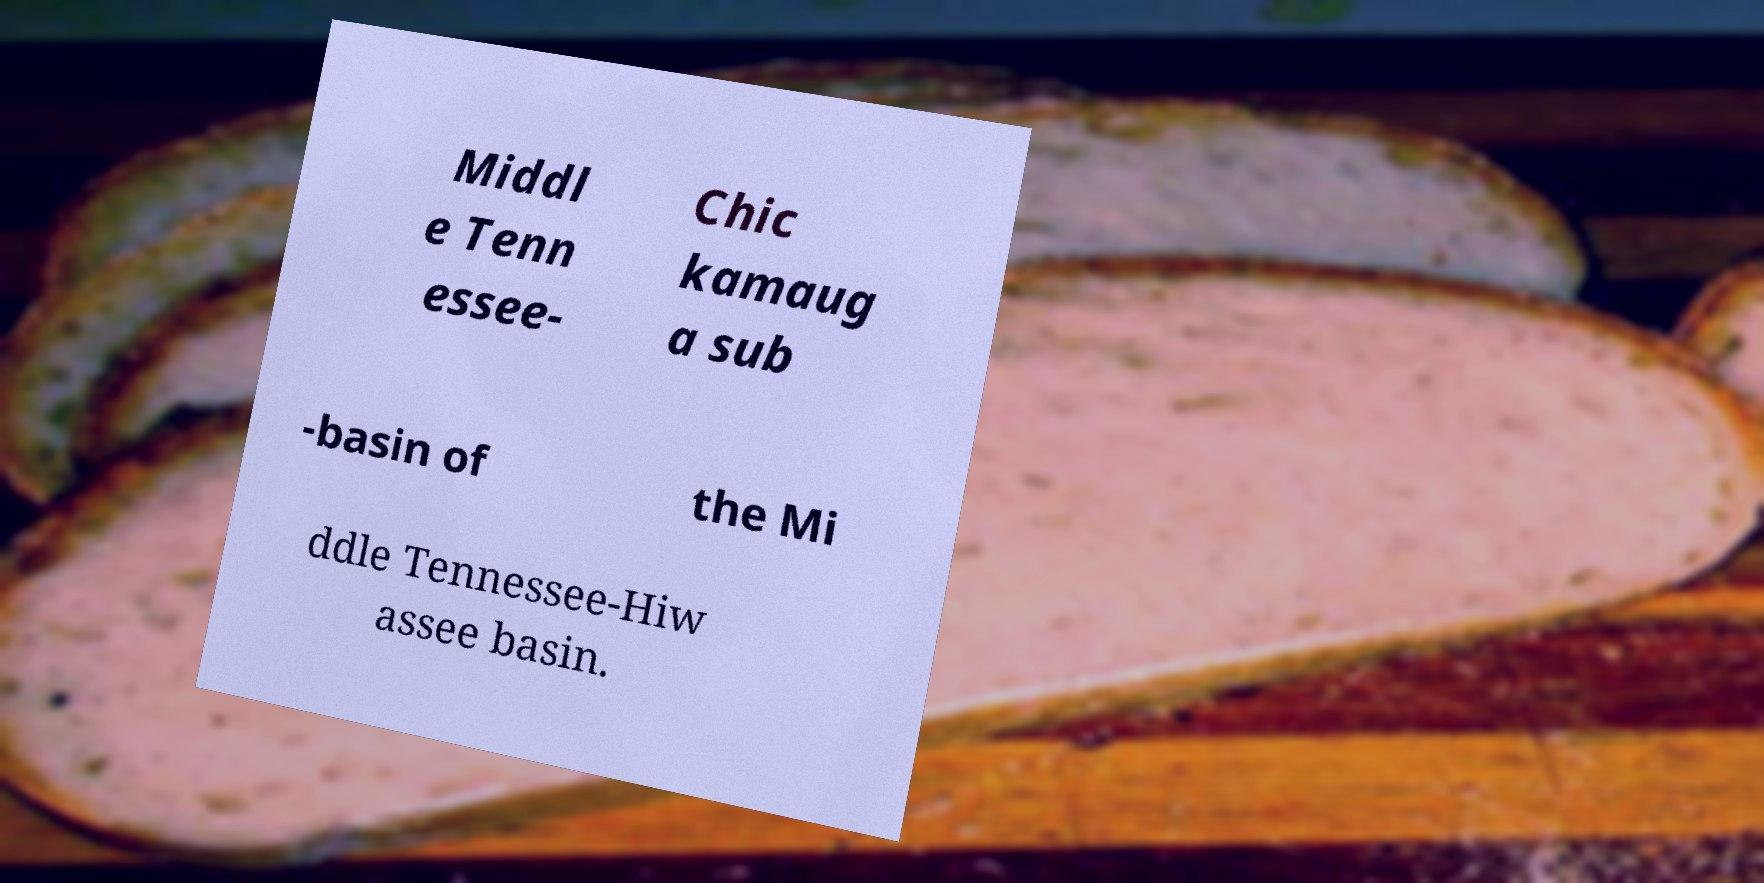Could you assist in decoding the text presented in this image and type it out clearly? Middl e Tenn essee- Chic kamaug a sub -basin of the Mi ddle Tennessee-Hiw assee basin. 